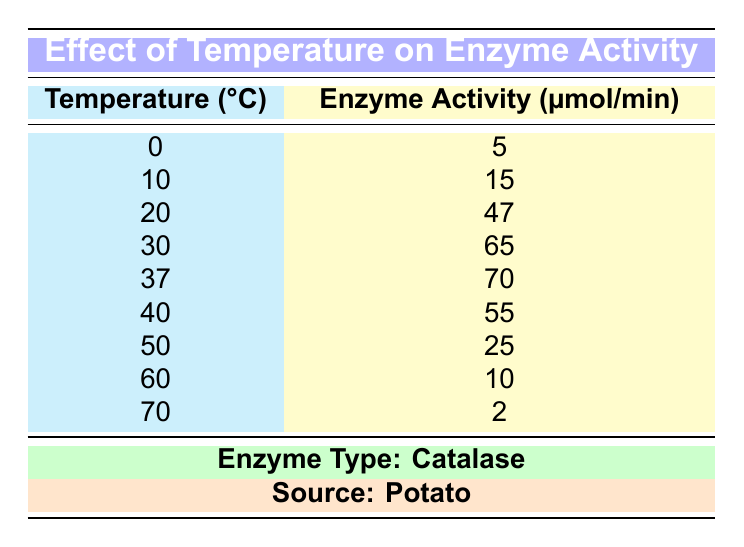What is the enzyme activity at 37°C? The table shows that at 37°C, the enzyme activity is 70 µmol/min.
Answer: 70 µmol/min What is the enzyme activity at 0°C? The enzyme activity at 0°C is 5 µmol/min, as stated in the table.
Answer: 5 µmol/min What is the highest enzyme activity recorded in the table? The highest enzyme activity recorded is 70 µmol/min at 37°C.
Answer: 70 µmol/min At which temperature did the enzyme activity decrease after increasing? The enzyme activity increased until 37°C and then decreased at 40°C, indicating that the enzyme activity began to decline after reaching its peak at 37°C.
Answer: 40°C What is the average enzyme activity between 10°C and 50°C? The values for enzyme activity at 10°C, 20°C, 30°C, 37°C, and 50°C are 15, 47, 65, 70, and 25 µmol/min respectively. Adding these gives 15 + 47 + 65 + 70 + 25 = 222. Since there are 5 temperatures, dividing 222 by 5 gives an average of 44.4 µmol/min.
Answer: 44.4 µmol/min Is the enzyme activity greater at 30°C than at 40°C? The enzyme activity at 30°C is 65 µmol/min, whereas at 40°C, it is 55 µmol/min. Therefore, the activity is indeed greater at 30°C.
Answer: Yes What temperature shows a significant decrease in enzyme activity compared to the previous temperature? Between 37°C (70 µmol/min) and 40°C (55 µmol/min), there is a significant decrease of 15 µmol/min. This is also seen between 50°C (25 µmol/min) and 60°C (10 µmol/min), where the decrease is 15 µmol/min again. Both indicate significant drops.
Answer: 40°C and 60°C How does the enzyme activity trend between 20°C and 70°C? The data shows that enzyme activity increases from 20°C (47 µmol/min) to 37°C (70 µmol/min), after which it decreases steadily to 2 µmol/min at 70°C. This indicates an initial increase followed by a decline.
Answer: Increase then decrease What is the difference in enzyme activity between 20°C and 60°C? At 20°C, enzyme activity is 47 µmol/min, and at 60°C, it is 10 µmol/min. The difference is calculated as 47 - 10 = 37 µmol/min.
Answer: 37 µmol/min 